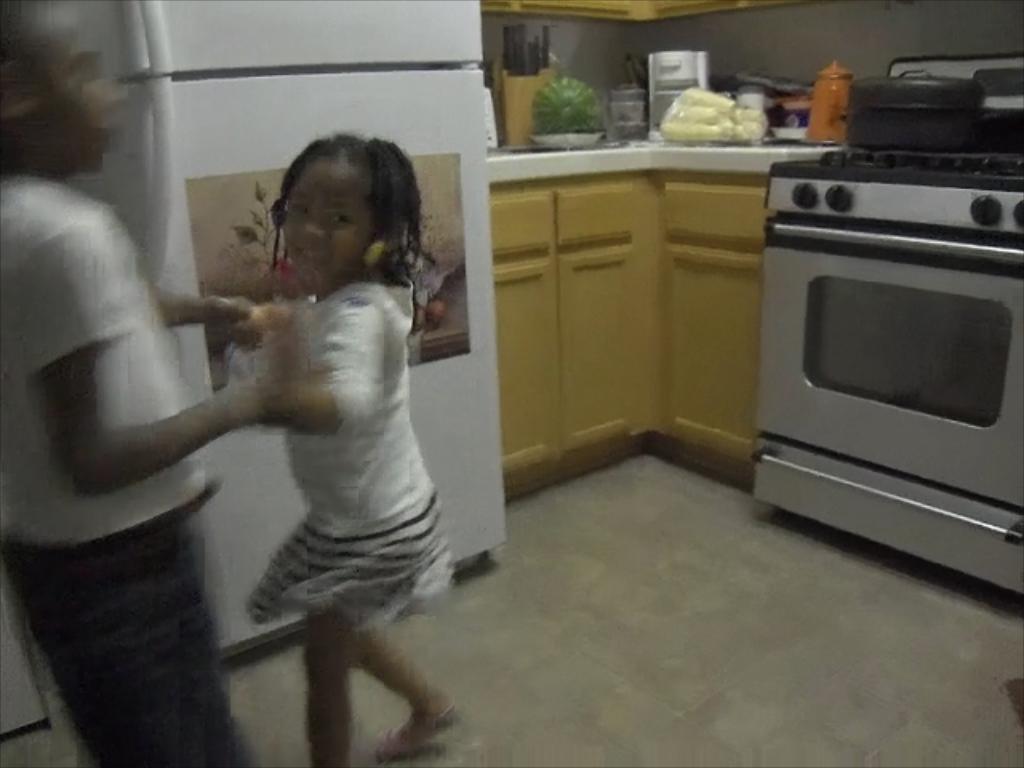Can you describe this image briefly? Here we can see a boy and girl. Poster is on the fridge. On this platform there are vegetables and things. Oven with stove. Above the stove there is an object. 